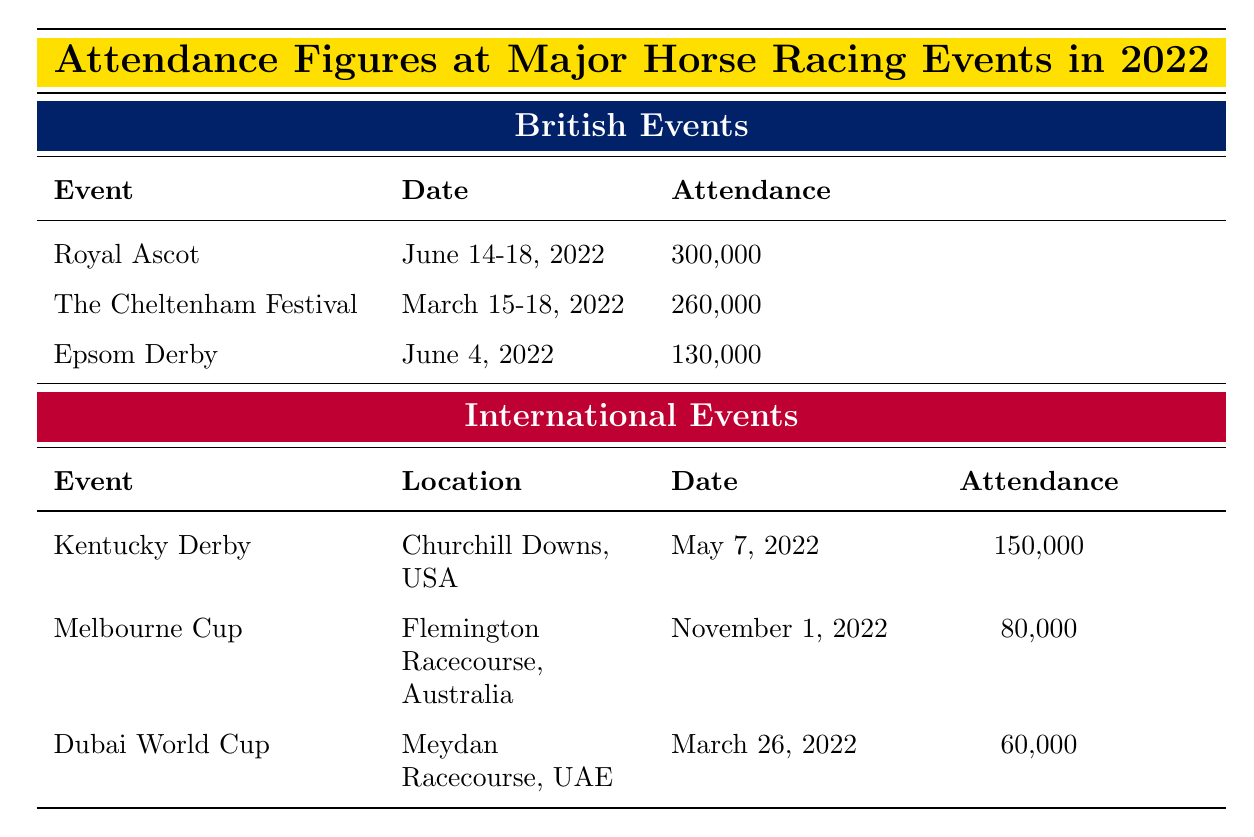What's the attendance at Royal Ascot? The table directly states that the attendance at Royal Ascot is 300,000.
Answer: 300,000 What date was The Cheltenham Festival held? The table specifies that The Cheltenham Festival took place from March 15 to 18, 2022.
Answer: March 15-18, 2022 Which event had the highest attendance among British events? By comparing the attendance figures, Royal Ascot has an attendance of 300,000, which is higher than The Cheltenham Festival's 260,000 and Epsom Derby's 130,000.
Answer: Royal Ascot Is the attendance at the Melbourne Cup greater than 90,000? The table shows that the attendance at the Melbourne Cup is 80,000, which is less than 90,000. Hence, the answer is no.
Answer: No What is the total attendance of all British events listed? The total attendance is calculated by adding the attendance figures of Royal Ascot (300,000), The Cheltenham Festival (260,000), and Epsom Derby (130,000). Thus, 300,000 + 260,000 + 130,000 equals 690,000.
Answer: 690,000 Which had a lower attendance, the Dubai World Cup or the Melbourne Cup? The Dubai World Cup had an attendance of 60,000 and the Melbourne Cup had 80,000. Comparing these figures, Dubai World Cup has the lower attendance.
Answer: Dubai World Cup What is the average attendance for the international events listed? To find the average, we sum the attendance numbers: Kentucky Derby (150,000), Melbourne Cup (80,000), and Dubai World Cup (60,000), which equals 290,000. We then divide this sum by the number of events, which is three. Therefore, the average attendance is 290,000 divided by 3, resulting in 96,666.67, which can be rounded to 96,667.
Answer: 96,667 Was the Epsom Derby attended by more than 120,000 people? The attendance at Epsom Derby is 130,000, which is indeed more than 120,000, confirming that the statement is true.
Answer: Yes Which event had the least attendance among all the listed events? By comparing attendance figures, the Dubai World Cup has the lowest attendance at 60,000, less than all other events.
Answer: Dubai World Cup 